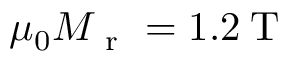<formula> <loc_0><loc_0><loc_500><loc_500>\mu _ { 0 } M _ { r } = 1 . 2 \, T</formula> 